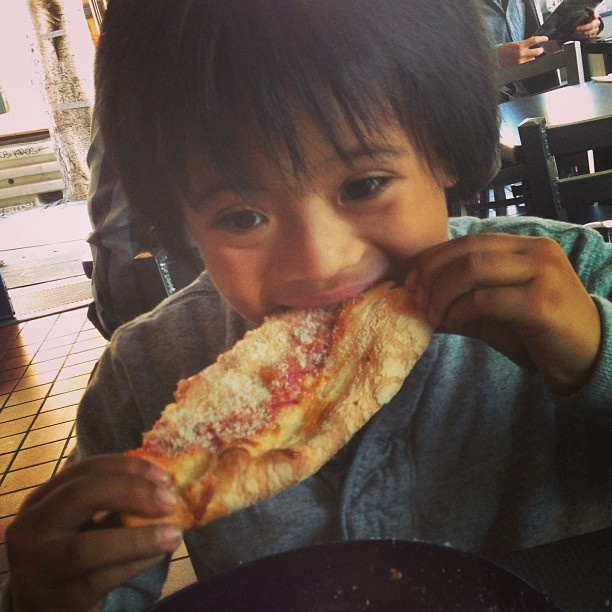Describe the objects in this image and their specific colors. I can see people in pink, black, maroon, gray, and brown tones, pizza in pink, tan, brown, and salmon tones, dining table in pink, black, maroon, and gray tones, people in pink, black, gray, and lightgray tones, and chair in lightgray, black, gray, and darkgray tones in this image. 